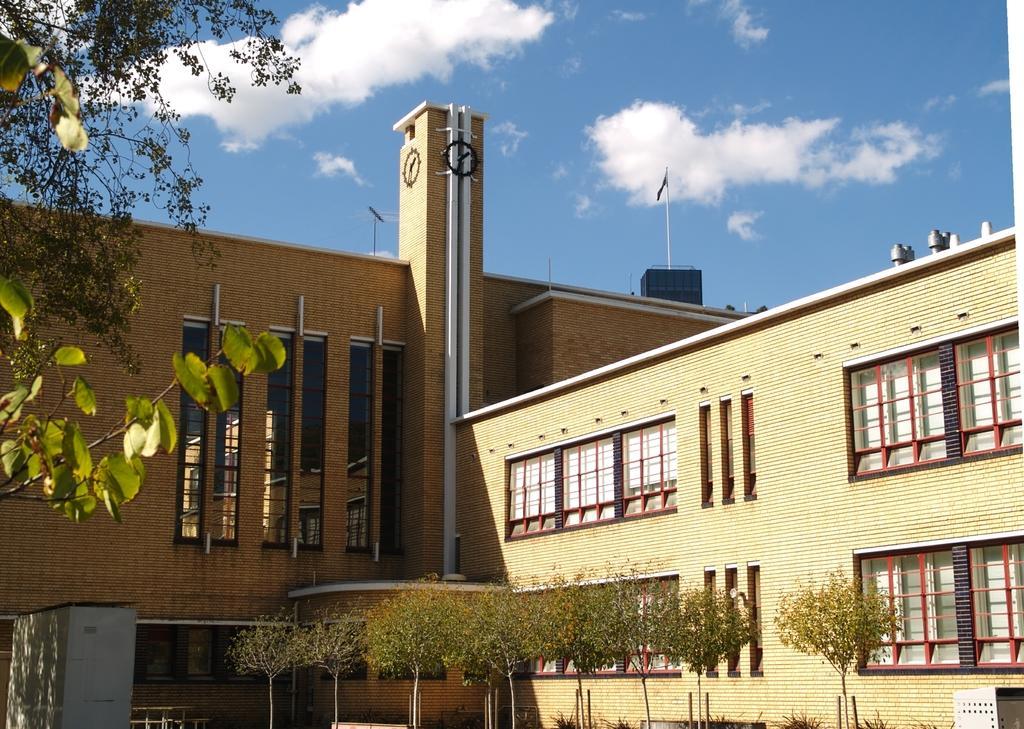Describe this image in one or two sentences. In this image we can see the front view of a building, there are trees in front of the building and there is a flag on top of the building. 